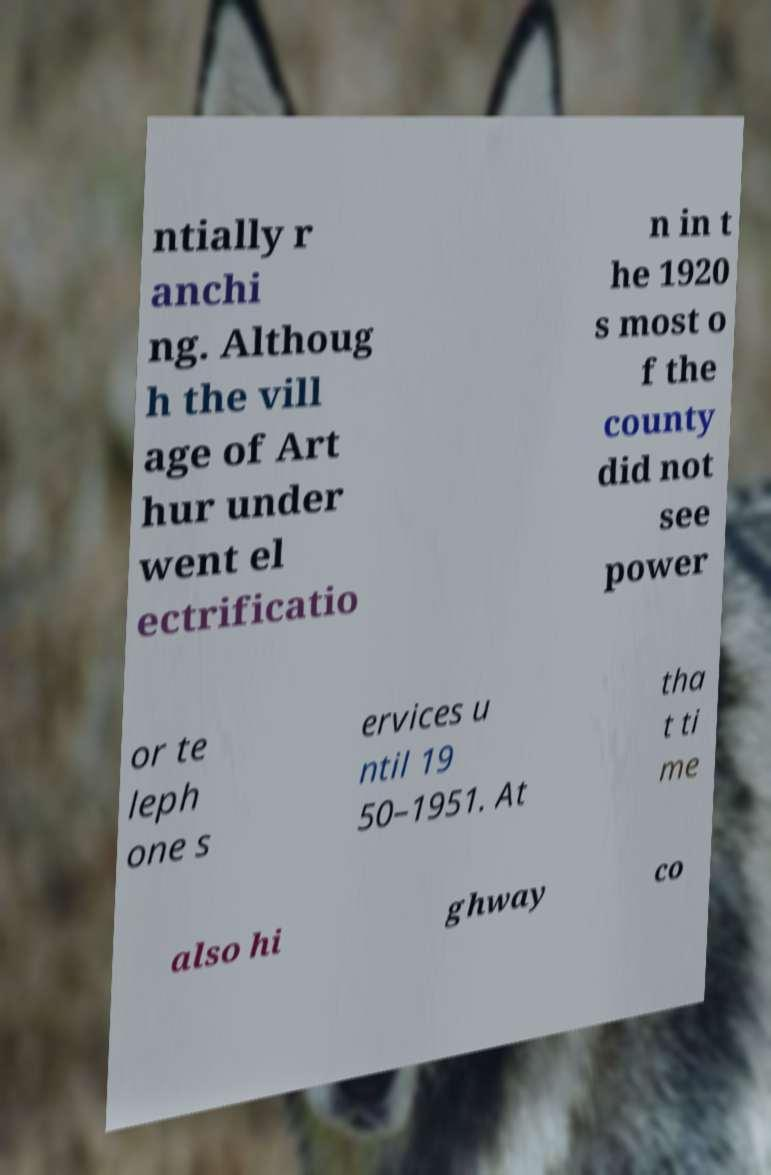Can you read and provide the text displayed in the image?This photo seems to have some interesting text. Can you extract and type it out for me? ntially r anchi ng. Althoug h the vill age of Art hur under went el ectrificatio n in t he 1920 s most o f the county did not see power or te leph one s ervices u ntil 19 50–1951. At tha t ti me also hi ghway co 